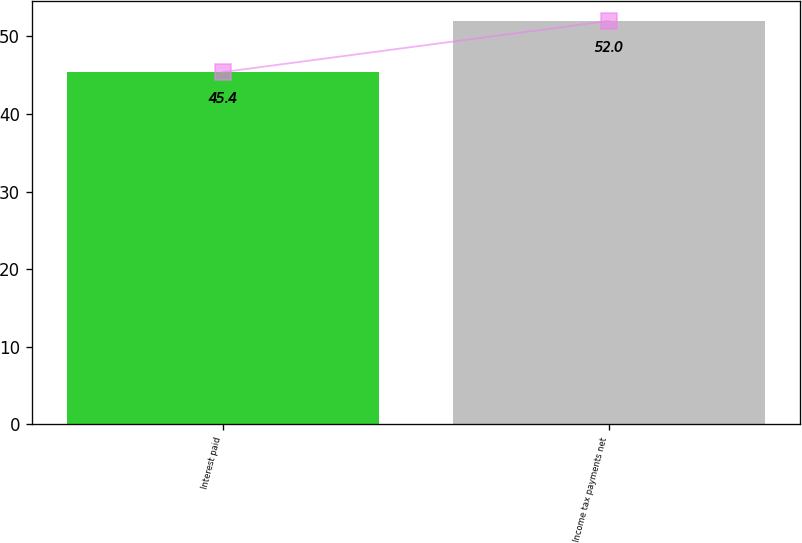<chart> <loc_0><loc_0><loc_500><loc_500><bar_chart><fcel>Interest paid<fcel>Income tax payments net<nl><fcel>45.4<fcel>52<nl></chart> 